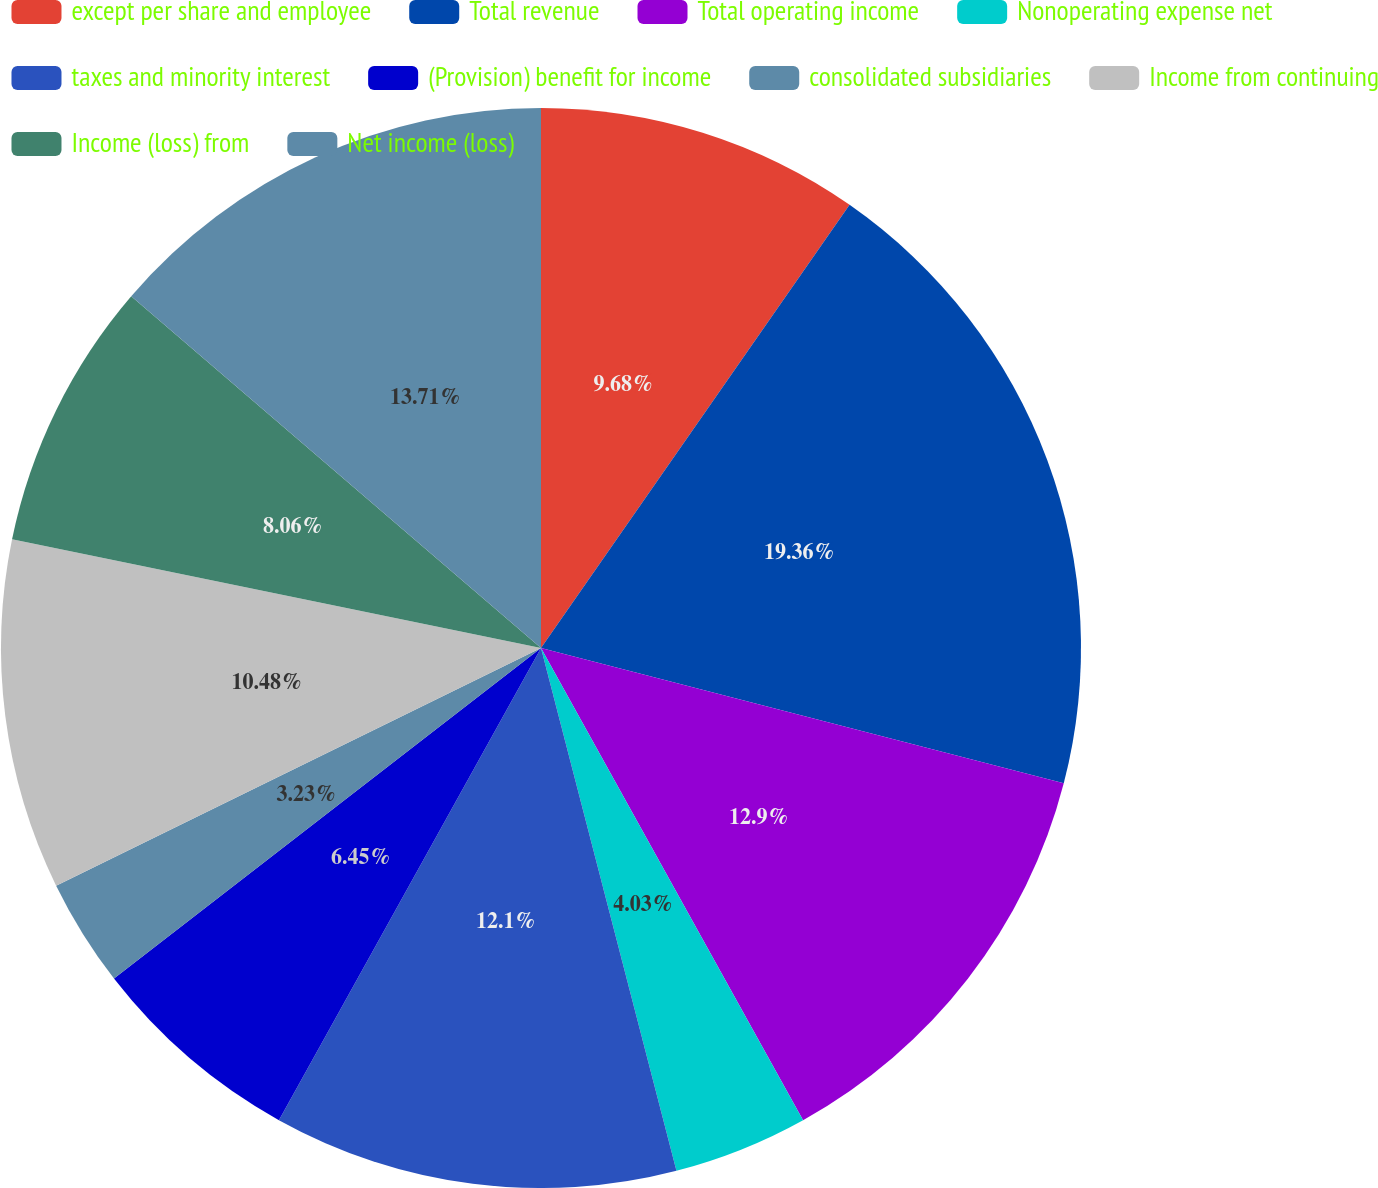Convert chart. <chart><loc_0><loc_0><loc_500><loc_500><pie_chart><fcel>except per share and employee<fcel>Total revenue<fcel>Total operating income<fcel>Nonoperating expense net<fcel>taxes and minority interest<fcel>(Provision) benefit for income<fcel>consolidated subsidiaries<fcel>Income from continuing<fcel>Income (loss) from<fcel>Net income (loss)<nl><fcel>9.68%<fcel>19.35%<fcel>12.9%<fcel>4.03%<fcel>12.1%<fcel>6.45%<fcel>3.23%<fcel>10.48%<fcel>8.06%<fcel>13.71%<nl></chart> 